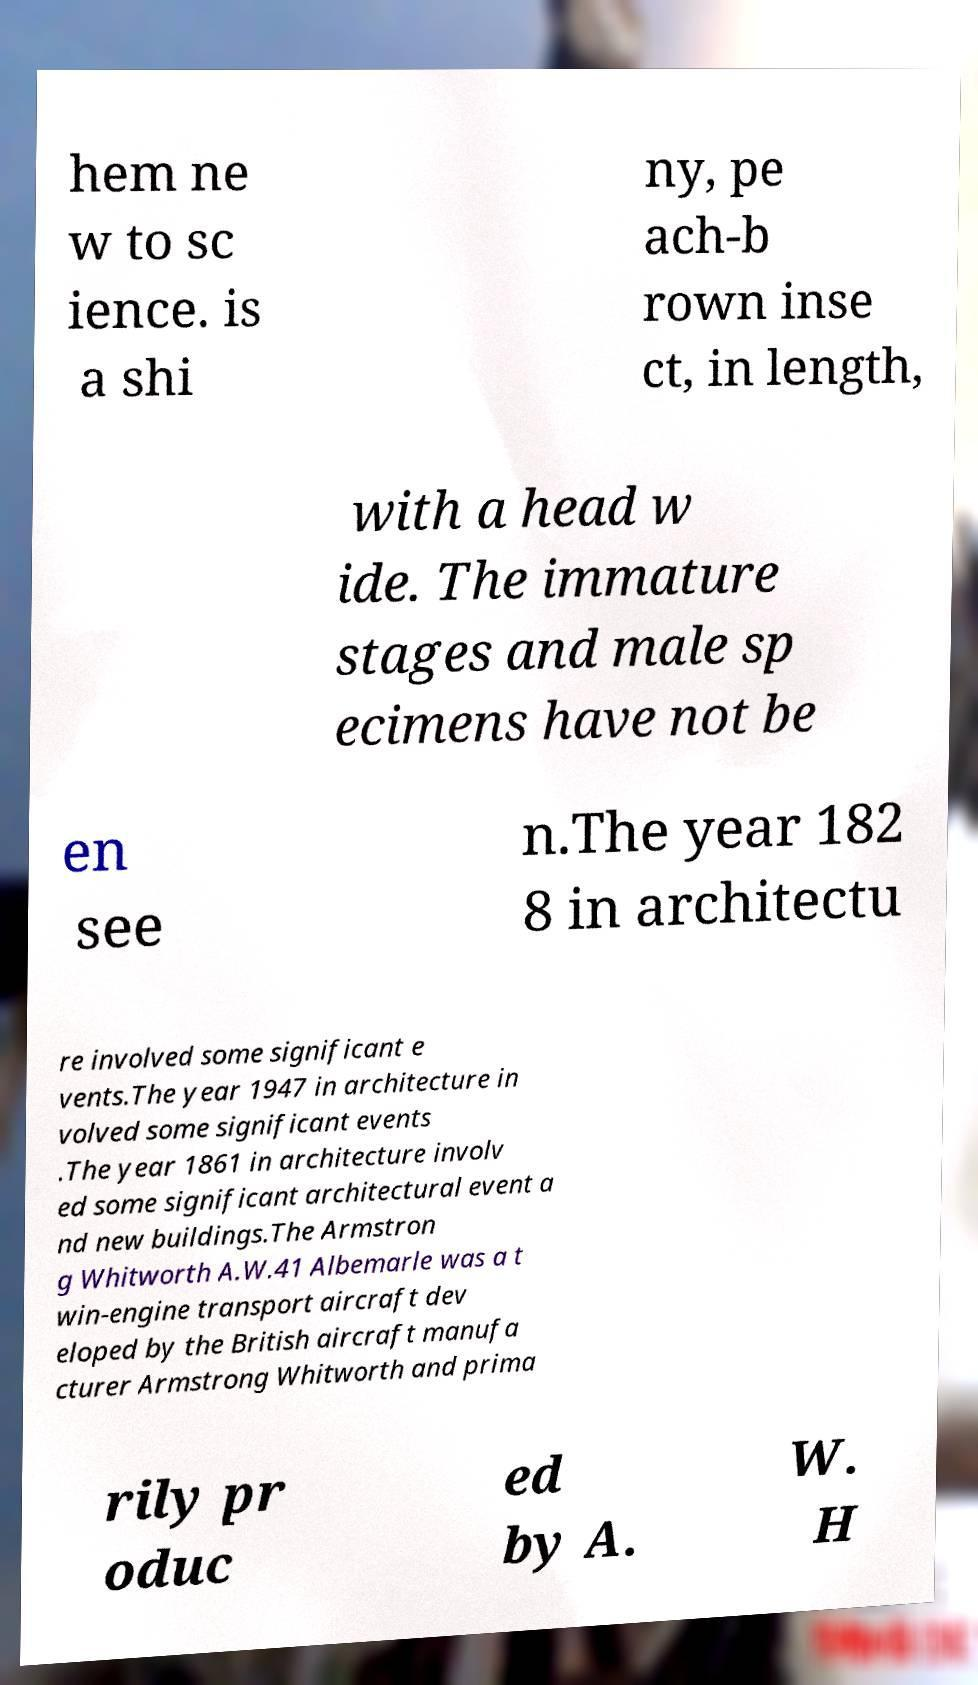I need the written content from this picture converted into text. Can you do that? hem ne w to sc ience. is a shi ny, pe ach-b rown inse ct, in length, with a head w ide. The immature stages and male sp ecimens have not be en see n.The year 182 8 in architectu re involved some significant e vents.The year 1947 in architecture in volved some significant events .The year 1861 in architecture involv ed some significant architectural event a nd new buildings.The Armstron g Whitworth A.W.41 Albemarle was a t win-engine transport aircraft dev eloped by the British aircraft manufa cturer Armstrong Whitworth and prima rily pr oduc ed by A. W. H 